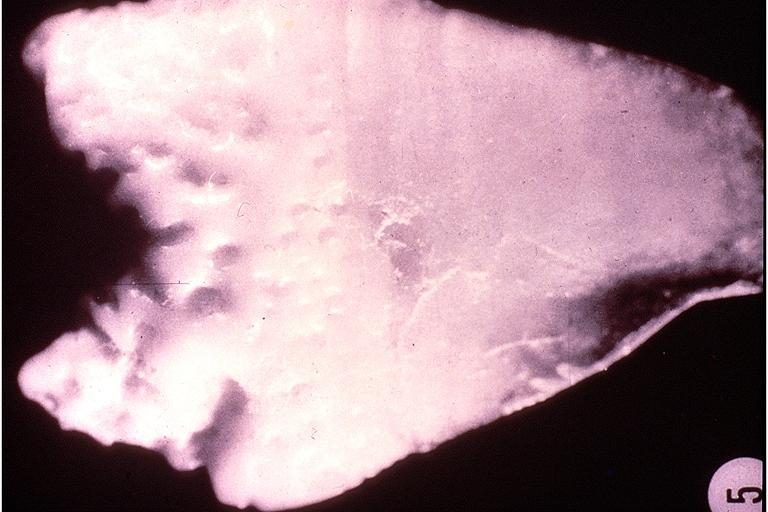where is this?
Answer the question using a single word or phrase. Oral 